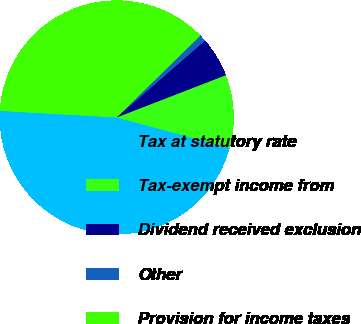Convert chart. <chart><loc_0><loc_0><loc_500><loc_500><pie_chart><fcel>Tax at statutory rate<fcel>Tax-exempt income from<fcel>Dividend received exclusion<fcel>Other<fcel>Provision for income taxes<nl><fcel>46.69%<fcel>10.08%<fcel>5.51%<fcel>0.93%<fcel>36.79%<nl></chart> 